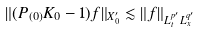<formula> <loc_0><loc_0><loc_500><loc_500>\| ( P _ { ( 0 ) } K _ { 0 } - 1 ) f \| _ { X _ { 0 } ^ { \prime } } \lesssim \| f \| _ { L _ { t } ^ { p ^ { \prime } } L _ { x } ^ { q ^ { \prime } } }</formula> 